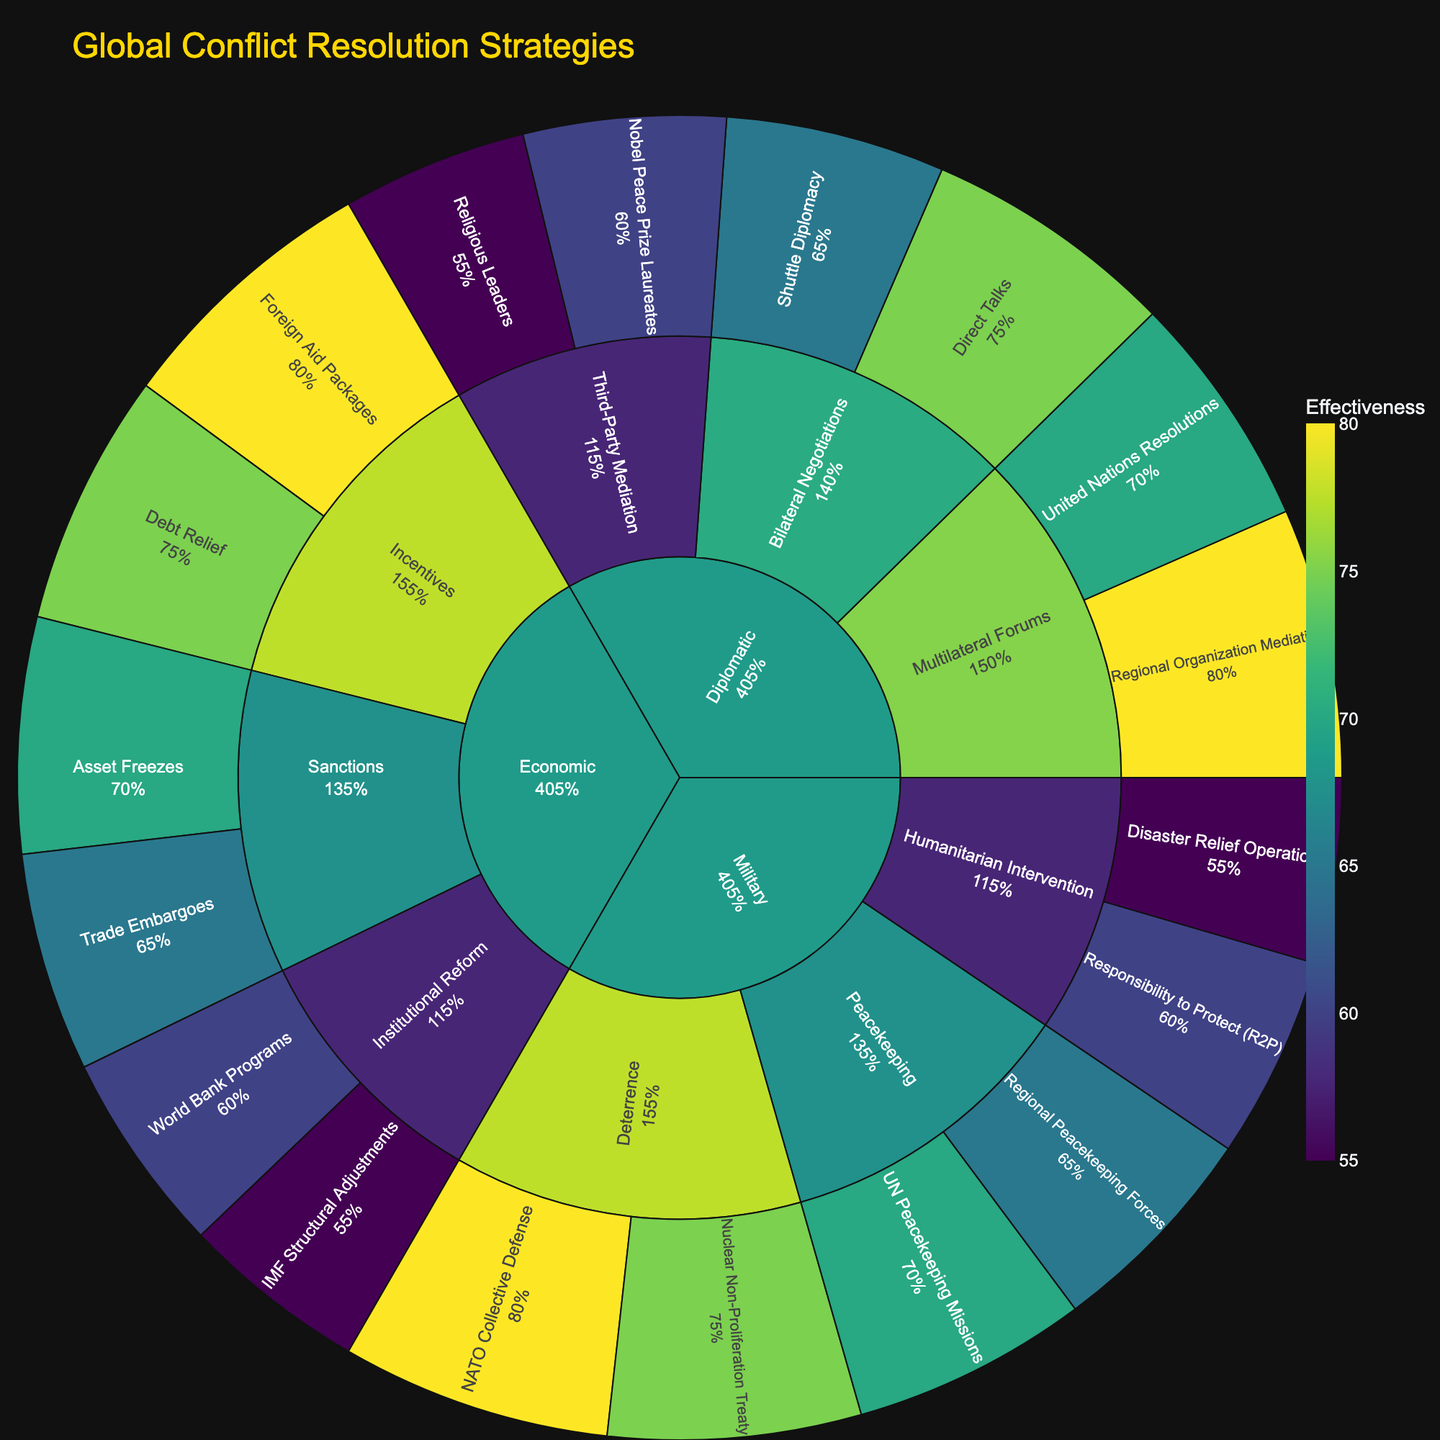What is the title of the sunburst plot? The title is typically displayed at the top of the plot. In this case, you'll find the title "Global Conflict Resolution Strategies" there.
Answer: Global Conflict Resolution Strategies Which approach within the Diplomatic category has the highest effectiveness? To find the most effective approach, look at the values within the Diplomatic category and compare them. The highest effectiveness under Diplomatic is the "Regional Organization Mediation" under "Multilateral Forums" with 80%.
Answer: Multilateral Forums - Regional Organization Mediation What is the total effectiveness score of all strategies under Economic approaches? Sum up the effectiveness values of all strategies under the Economic approaches: Trade Embargoes (65), Asset Freezes (70), Debt Relief (75), Foreign Aid Packages (80), World Bank Programs (60), and IMF Structural Adjustments (55). The total is 65 + 70 + 75 + 80 + 60 + 55 = 405.
Answer: 405 Which strategy under Military approaches has the lowest effectiveness? In the Military category, compare the effectiveness of each strategy. “Disaster Relief Operations” under "Humanitarian Intervention" has the lowest effectiveness at 55%.
Answer: Disaster Relief Operations What is the average effectiveness of the Incentives approach under Economic strategies? The Incentives approach includes Debt Relief (75) and Foreign Aid Packages (80). To find the average effectiveness: (75 + 80) / 2 = 77.5.
Answer: 77.5 Compare the effectiveness of Peacekeeping and Deterrence approaches under Military strategies. Which one is more effective? Compare the effectiveness score of strategies under Peacekeeping (70 and 65) versus Deterrence (80 and 75). The average effectiveness for Peacekeeping is (70 + 65) / 2 = 67.5 and for Deterrence is (80 + 75) / 2 = 77.5. Deterrence is more effective.
Answer: Deterrence What is the range of effectiveness values in the Diplomatic category? Identify the minimum and maximum effectiveness values within the Diplomatic category (55 and 80 respectively). The range is 80 - 55 = 25.
Answer: 25 Which category has the highest average effectiveness across all approaches and strategies? Calculate the average effectiveness for each category. Diplomatic: (75 + 65 + 70 + 80 + 60 + 55) / 6 = 67.5, Economic: (65 + 70 + 75 + 80 + 60 + 55) / 6 = 67.5, Military: (70 + 65 + 80 + 75 + 60 + 55) / 6 = 67.5. They all have an average effectiveness of 67.5.
Answer: All categories have the same average effectiveness Which third-party mediation strategy has higher effectiveness, "Nobel Peace Prize Laureates" or "Religious Leaders"? Compare the effectiveness values of "Nobel Peace Prize Laureates" (60) and "Religious Leaders" (55). "Nobel Peace Prize Laureates" is more effective.
Answer: Nobel Peace Prize Laureates 